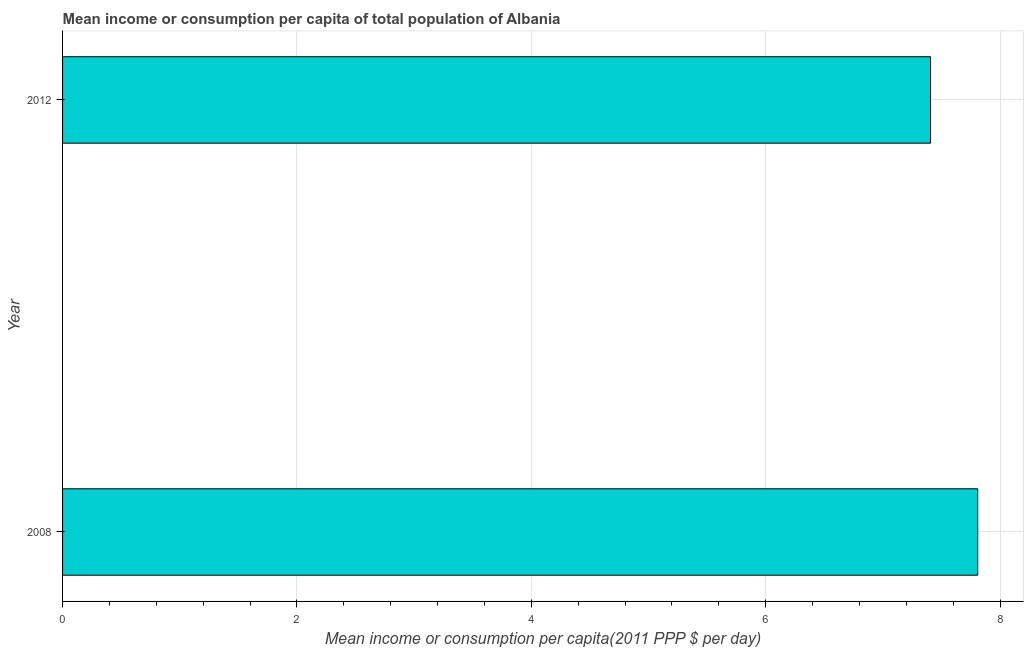What is the title of the graph?
Offer a very short reply. Mean income or consumption per capita of total population of Albania. What is the label or title of the X-axis?
Offer a terse response. Mean income or consumption per capita(2011 PPP $ per day). What is the label or title of the Y-axis?
Offer a terse response. Year. What is the mean income or consumption in 2008?
Your response must be concise. 7.81. Across all years, what is the maximum mean income or consumption?
Make the answer very short. 7.81. Across all years, what is the minimum mean income or consumption?
Ensure brevity in your answer.  7.41. What is the sum of the mean income or consumption?
Offer a terse response. 15.22. What is the difference between the mean income or consumption in 2008 and 2012?
Your response must be concise. 0.4. What is the average mean income or consumption per year?
Your answer should be very brief. 7.61. What is the median mean income or consumption?
Offer a very short reply. 7.61. In how many years, is the mean income or consumption greater than 6 $?
Provide a succinct answer. 2. What is the ratio of the mean income or consumption in 2008 to that in 2012?
Provide a succinct answer. 1.05. Is the mean income or consumption in 2008 less than that in 2012?
Give a very brief answer. No. How many bars are there?
Your response must be concise. 2. How many years are there in the graph?
Keep it short and to the point. 2. What is the Mean income or consumption per capita(2011 PPP $ per day) in 2008?
Give a very brief answer. 7.81. What is the Mean income or consumption per capita(2011 PPP $ per day) in 2012?
Give a very brief answer. 7.41. What is the difference between the Mean income or consumption per capita(2011 PPP $ per day) in 2008 and 2012?
Your response must be concise. 0.4. What is the ratio of the Mean income or consumption per capita(2011 PPP $ per day) in 2008 to that in 2012?
Your answer should be compact. 1.05. 